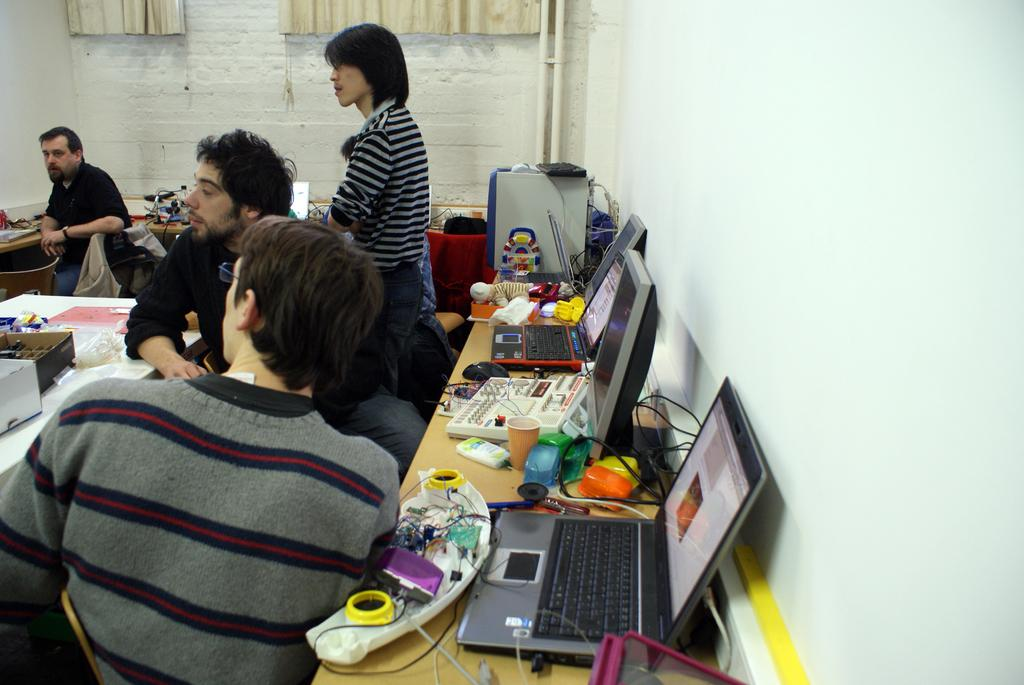What can be seen in the image? There are people, laptops, monitors, cables, mice, and objects on tables in the image. What is the purpose of the mice in the image? The mice are likely used for controlling the laptops and monitors in the image. What is visible in the background of the image? There are curtains, pipes, and a wall in the background of the image. What type of grip can be seen on the metal objects in the image? There is no mention of metal objects in the image, and therefore no grip can be observed. 